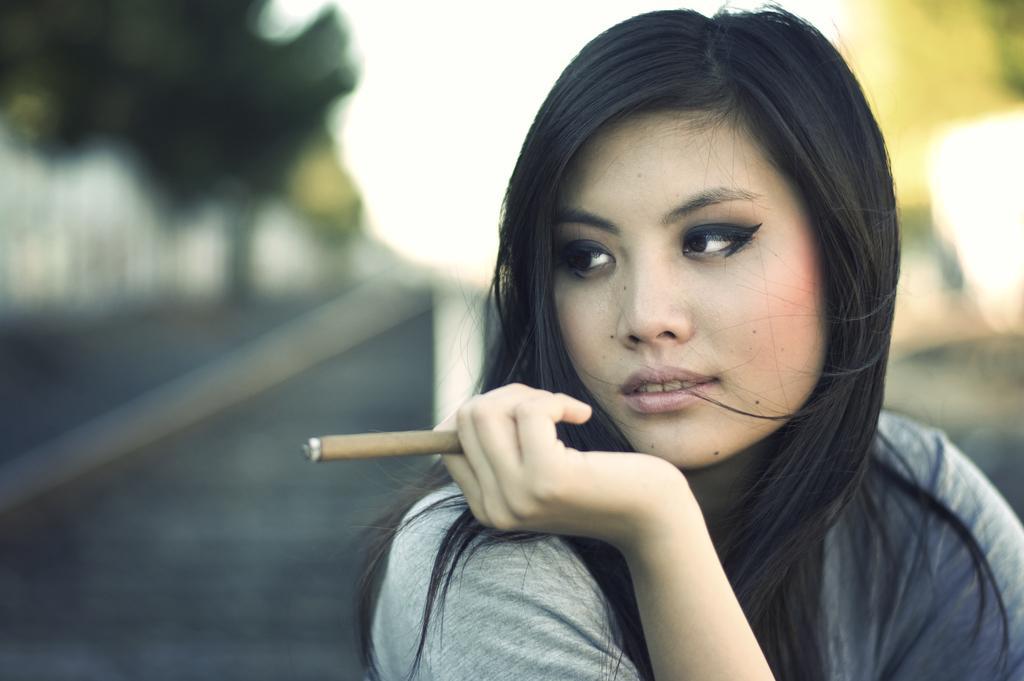In one or two sentences, can you explain what this image depicts? In this image I can see the person holding some object and the person is wearing gray color shirt and I can see the blurred background. 